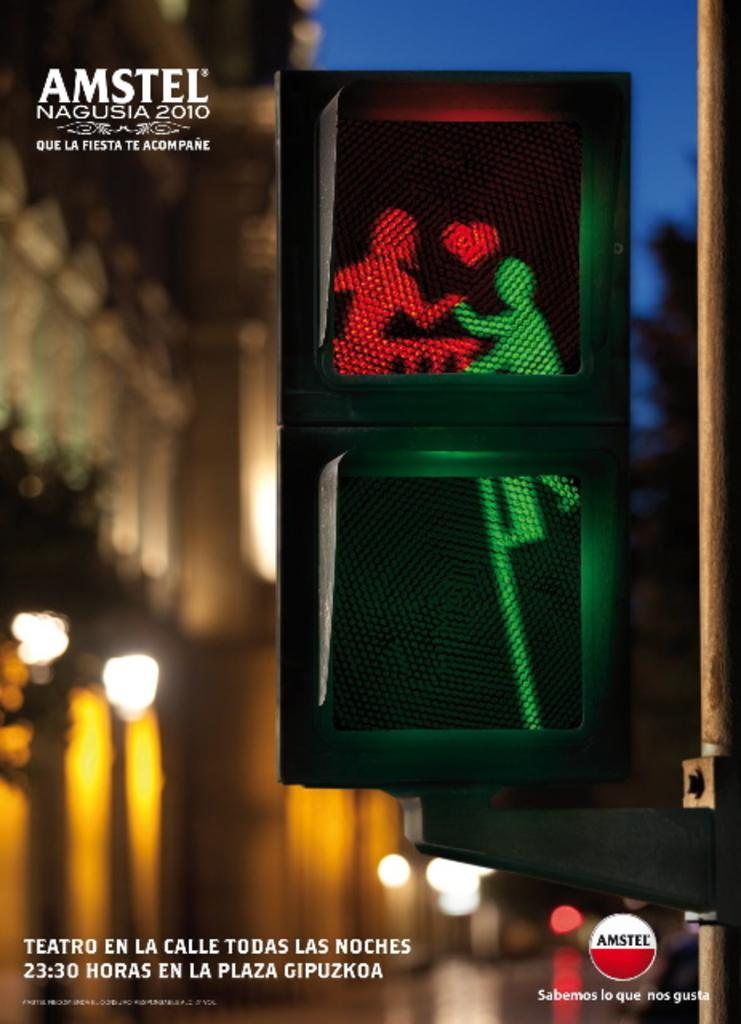<image>
Write a terse but informative summary of the picture. The text next to the a street walk sign says "Teatro en la Calle todas las noches". 